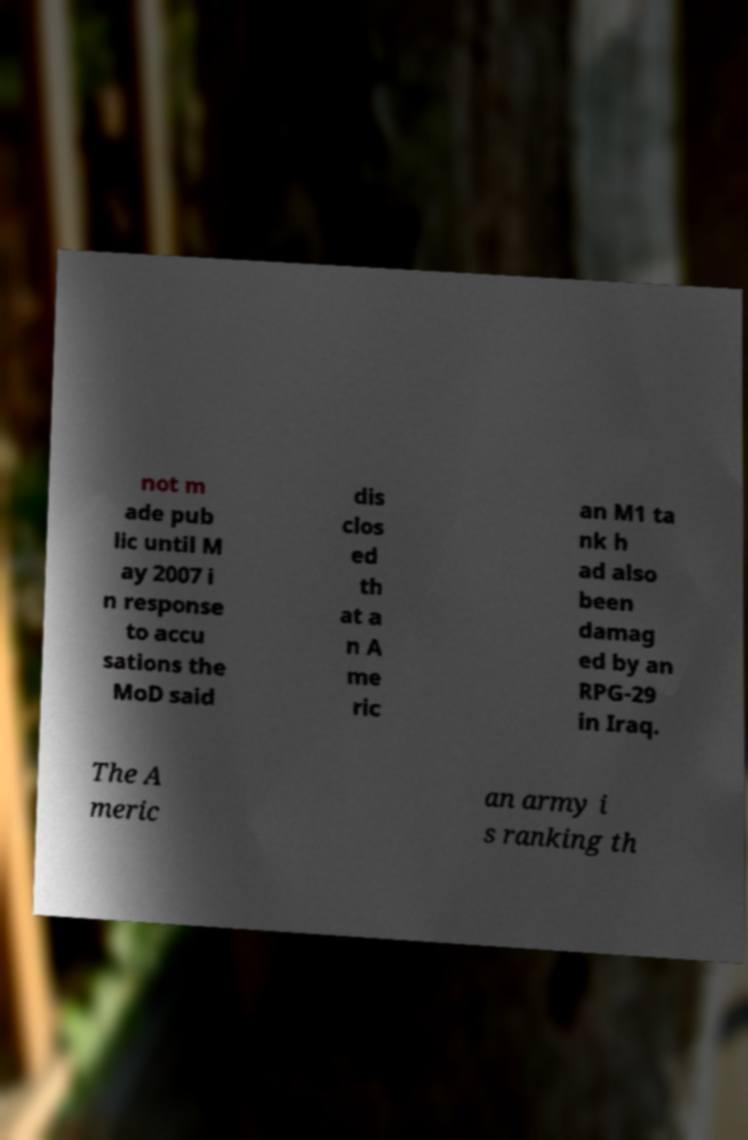Can you accurately transcribe the text from the provided image for me? not m ade pub lic until M ay 2007 i n response to accu sations the MoD said dis clos ed th at a n A me ric an M1 ta nk h ad also been damag ed by an RPG-29 in Iraq. The A meric an army i s ranking th 